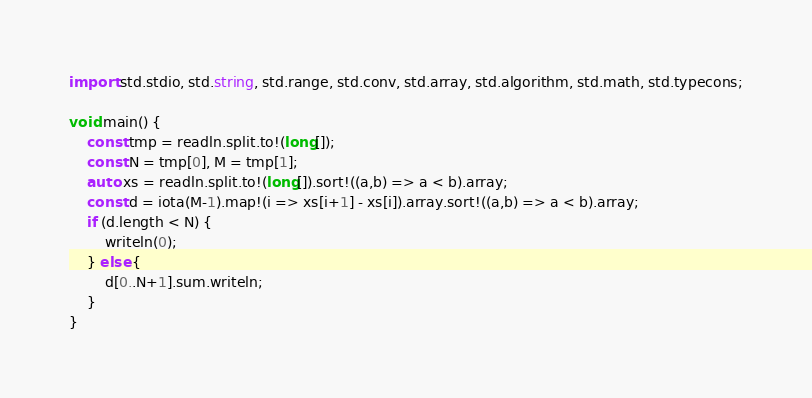Convert code to text. <code><loc_0><loc_0><loc_500><loc_500><_D_>import std.stdio, std.string, std.range, std.conv, std.array, std.algorithm, std.math, std.typecons;

void main() {
    const tmp = readln.split.to!(long[]);
    const N = tmp[0], M = tmp[1];
    auto xs = readln.split.to!(long[]).sort!((a,b) => a < b).array;
    const d = iota(M-1).map!(i => xs[i+1] - xs[i]).array.sort!((a,b) => a < b).array;
    if (d.length < N) {
        writeln(0);
    } else {
        d[0..N+1].sum.writeln;
    }
}
</code> 